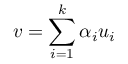<formula> <loc_0><loc_0><loc_500><loc_500>v = \sum _ { i = 1 } ^ { k } \alpha _ { i } u _ { i }</formula> 